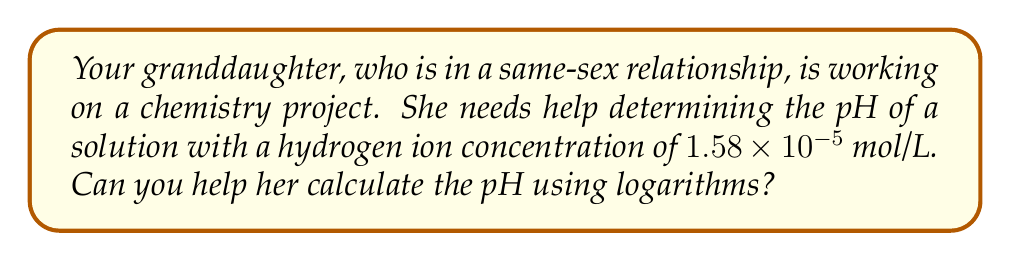Teach me how to tackle this problem. Let's approach this step-by-step:

1) The pH of a solution is defined as the negative logarithm (base 10) of the hydrogen ion concentration [H+]:

   $$ pH = -\log_{10}[H^+] $$

2) We're given that the hydrogen ion concentration [H+] is $1.58 \times 10^{-5}$ mol/L.

3) Let's substitute this into our pH equation:

   $$ pH = -\log_{10}(1.58 \times 10^{-5}) $$

4) Using the properties of logarithms, we can split this into two parts:

   $$ pH = -(\log_{10}(1.58) + \log_{10}(10^{-5})) $$

5) We know that $\log_{10}(10^{-5}) = -5$, so:

   $$ pH = -(\log_{10}(1.58) - 5) $$

6) Using a calculator or logarithm table, we can find that $\log_{10}(1.58) \approx 0.1987$

7) Now we can calculate:

   $$ pH = -(0.1987 - 5) = -0.1987 + 5 = 4.8013 $$

8) It's common to round pH to two decimal places, so our final answer is 4.80.
Answer: $4.80$ 